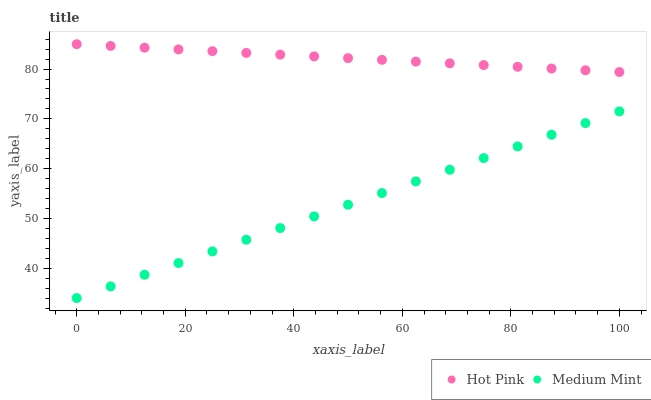Does Medium Mint have the minimum area under the curve?
Answer yes or no. Yes. Does Hot Pink have the maximum area under the curve?
Answer yes or no. Yes. Does Hot Pink have the minimum area under the curve?
Answer yes or no. No. Is Medium Mint the smoothest?
Answer yes or no. Yes. Is Hot Pink the roughest?
Answer yes or no. Yes. Is Hot Pink the smoothest?
Answer yes or no. No. Does Medium Mint have the lowest value?
Answer yes or no. Yes. Does Hot Pink have the lowest value?
Answer yes or no. No. Does Hot Pink have the highest value?
Answer yes or no. Yes. Is Medium Mint less than Hot Pink?
Answer yes or no. Yes. Is Hot Pink greater than Medium Mint?
Answer yes or no. Yes. Does Medium Mint intersect Hot Pink?
Answer yes or no. No. 